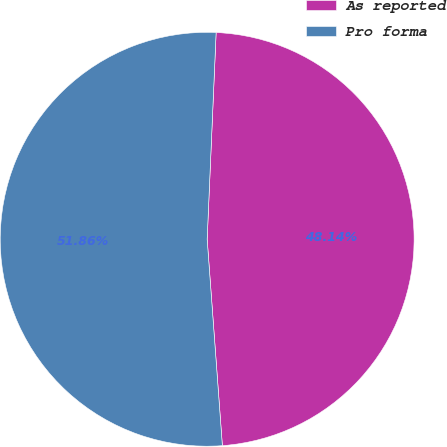<chart> <loc_0><loc_0><loc_500><loc_500><pie_chart><fcel>As reported<fcel>Pro forma<nl><fcel>48.14%<fcel>51.86%<nl></chart> 